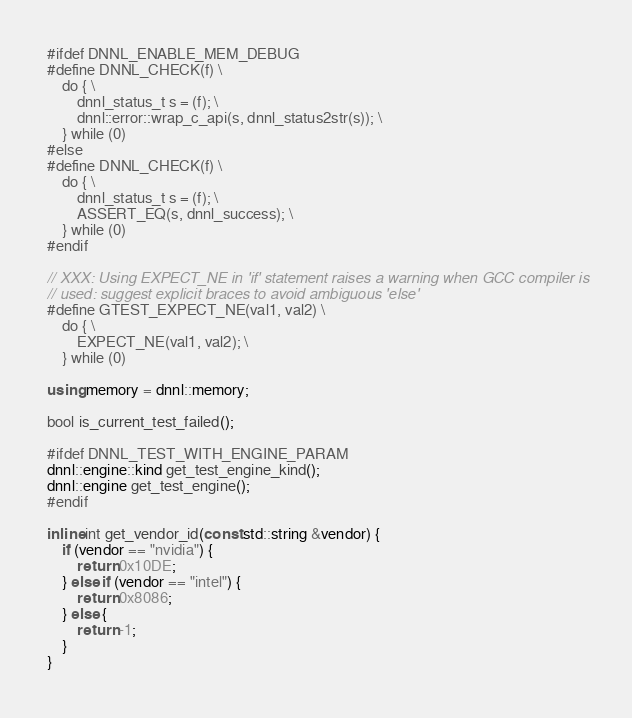<code> <loc_0><loc_0><loc_500><loc_500><_C++_>
#ifdef DNNL_ENABLE_MEM_DEBUG
#define DNNL_CHECK(f) \
    do { \
        dnnl_status_t s = (f); \
        dnnl::error::wrap_c_api(s, dnnl_status2str(s)); \
    } while (0)
#else
#define DNNL_CHECK(f) \
    do { \
        dnnl_status_t s = (f); \
        ASSERT_EQ(s, dnnl_success); \
    } while (0)
#endif

// XXX: Using EXPECT_NE in 'if' statement raises a warning when GCC compiler is
// used: suggest explicit braces to avoid ambiguous 'else'
#define GTEST_EXPECT_NE(val1, val2) \
    do { \
        EXPECT_NE(val1, val2); \
    } while (0)

using memory = dnnl::memory;

bool is_current_test_failed();

#ifdef DNNL_TEST_WITH_ENGINE_PARAM
dnnl::engine::kind get_test_engine_kind();
dnnl::engine get_test_engine();
#endif

inline int get_vendor_id(const std::string &vendor) {
    if (vendor == "nvidia") {
        return 0x10DE;
    } else if (vendor == "intel") {
        return 0x8086;
    } else {
        return -1;
    }
}
</code> 